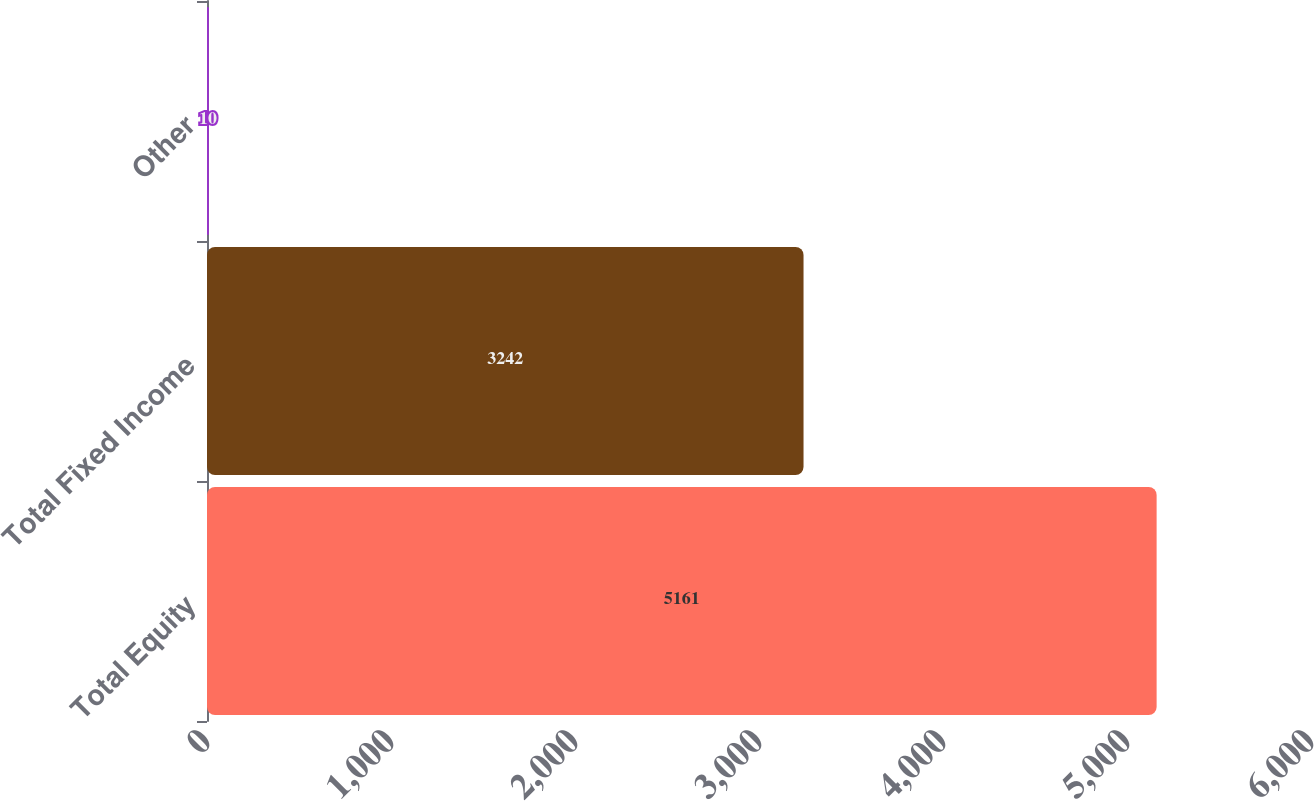Convert chart. <chart><loc_0><loc_0><loc_500><loc_500><bar_chart><fcel>Total Equity<fcel>Total Fixed Income<fcel>Other<nl><fcel>5161<fcel>3242<fcel>10<nl></chart> 